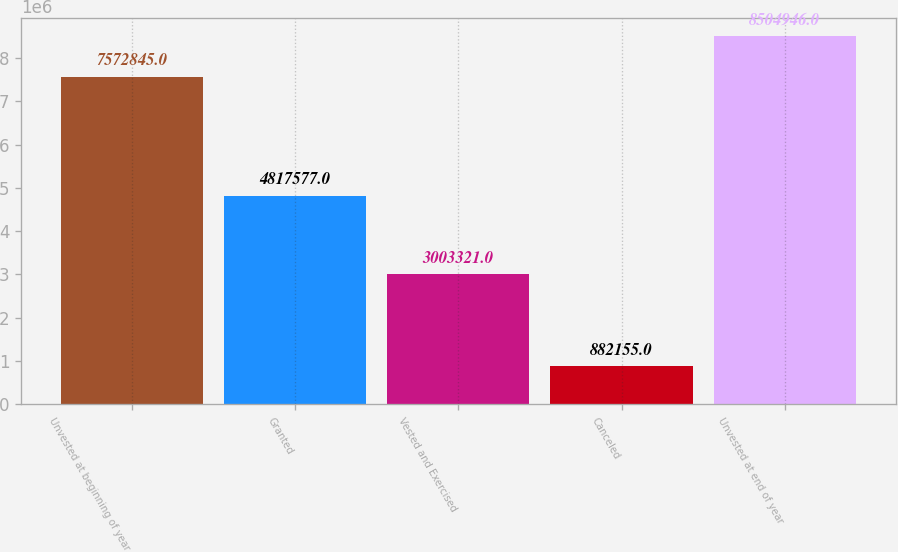Convert chart to OTSL. <chart><loc_0><loc_0><loc_500><loc_500><bar_chart><fcel>Unvested at beginning of year<fcel>Granted<fcel>Vested and Exercised<fcel>Canceled<fcel>Unvested at end of year<nl><fcel>7.57284e+06<fcel>4.81758e+06<fcel>3.00332e+06<fcel>882155<fcel>8.50495e+06<nl></chart> 